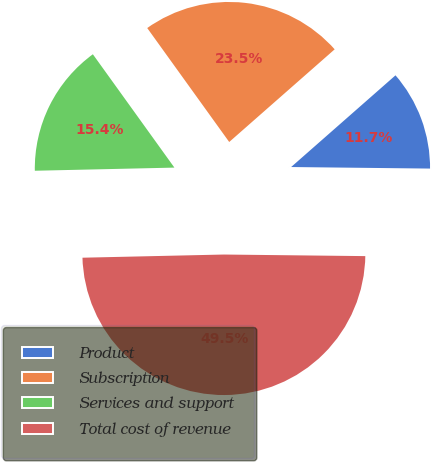Convert chart. <chart><loc_0><loc_0><loc_500><loc_500><pie_chart><fcel>Product<fcel>Subscription<fcel>Services and support<fcel>Total cost of revenue<nl><fcel>11.65%<fcel>23.45%<fcel>15.43%<fcel>49.46%<nl></chart> 